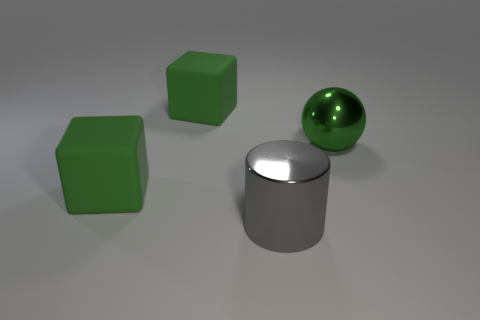Add 4 big gray objects. How many objects exist? 8 Subtract all spheres. How many objects are left? 3 Subtract all cubes. Subtract all metallic spheres. How many objects are left? 1 Add 2 large green matte objects. How many large green matte objects are left? 4 Add 3 gray objects. How many gray objects exist? 4 Subtract 0 blue cubes. How many objects are left? 4 